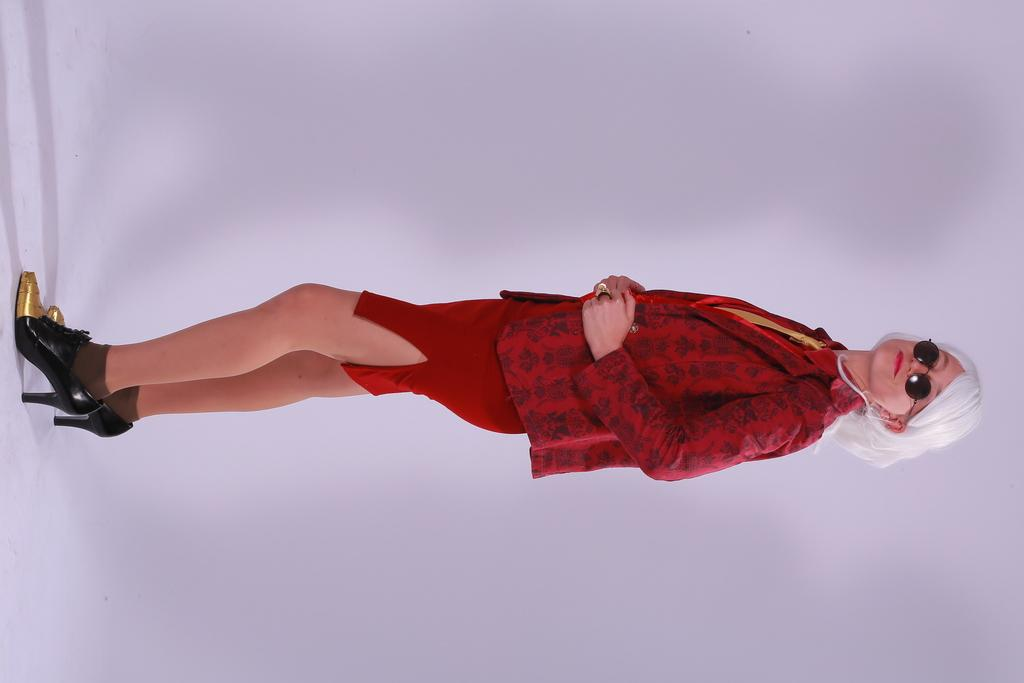Who is the main subject in the image? There is a woman standing in the middle of the image. What is the woman standing on? The woman is standing on a white surface. What can be seen in the background of the image? There is a white cloth in the background of the image. How many rabbits are present in the image? There are no rabbits present in the image. What time of day is it in the image, according to the hour? The provided facts do not mention the time of day or any hour, so it cannot be determined from the image. 